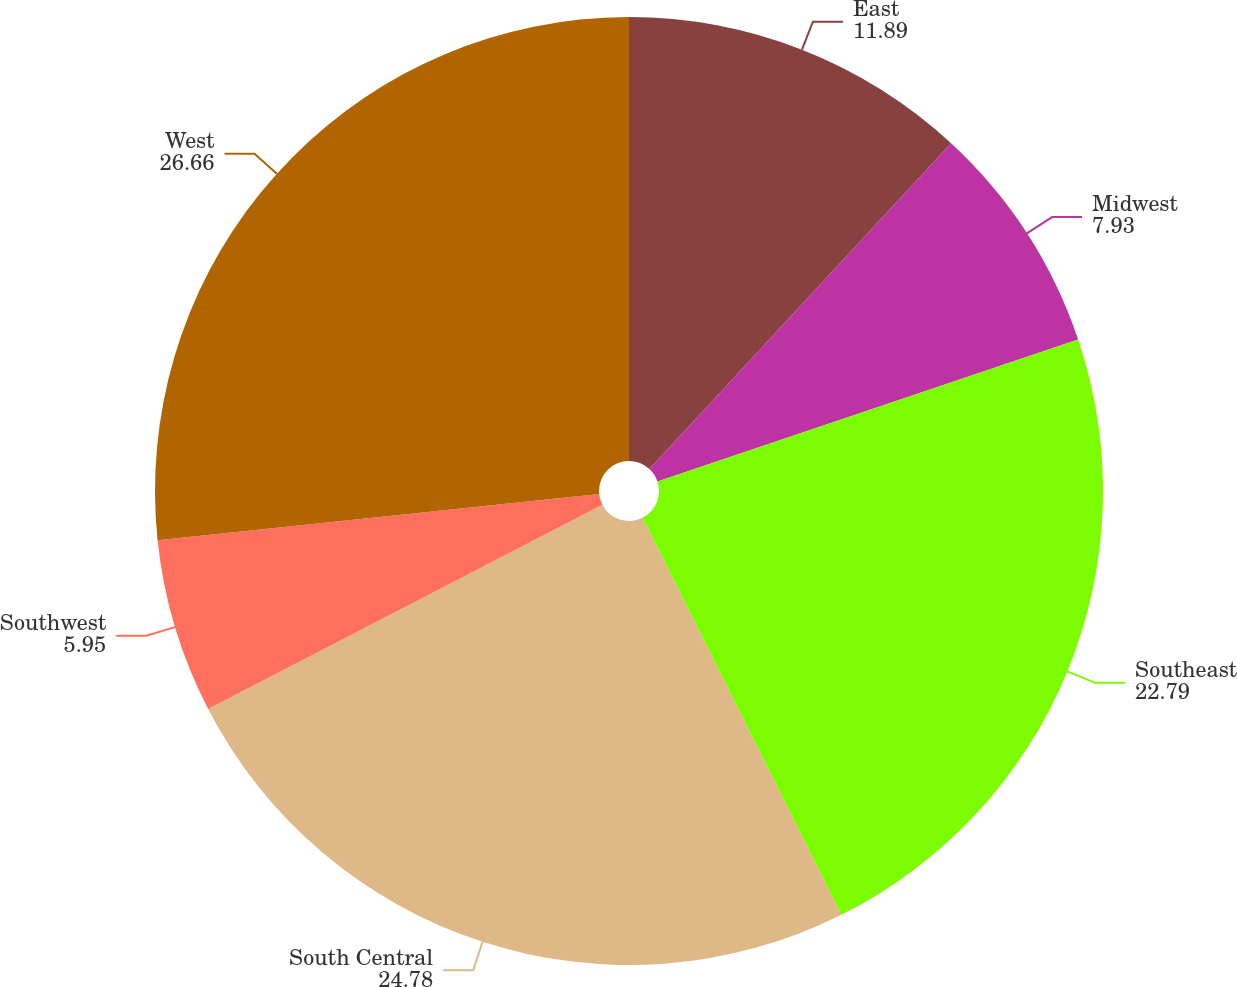Convert chart. <chart><loc_0><loc_0><loc_500><loc_500><pie_chart><fcel>East<fcel>Midwest<fcel>Southeast<fcel>South Central<fcel>Southwest<fcel>West<nl><fcel>11.89%<fcel>7.93%<fcel>22.79%<fcel>24.78%<fcel>5.95%<fcel>26.66%<nl></chart> 